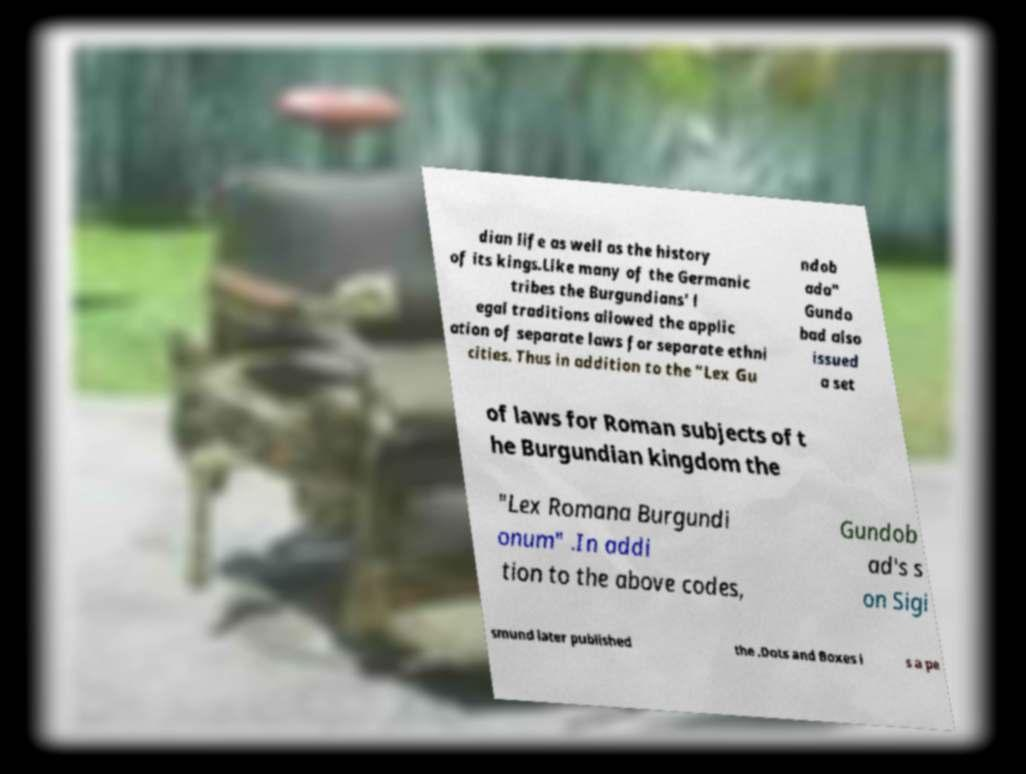Can you accurately transcribe the text from the provided image for me? dian life as well as the history of its kings.Like many of the Germanic tribes the Burgundians' l egal traditions allowed the applic ation of separate laws for separate ethni cities. Thus in addition to the "Lex Gu ndob ada" Gundo bad also issued a set of laws for Roman subjects of t he Burgundian kingdom the "Lex Romana Burgundi onum" .In addi tion to the above codes, Gundob ad's s on Sigi smund later published the .Dots and Boxes i s a pe 